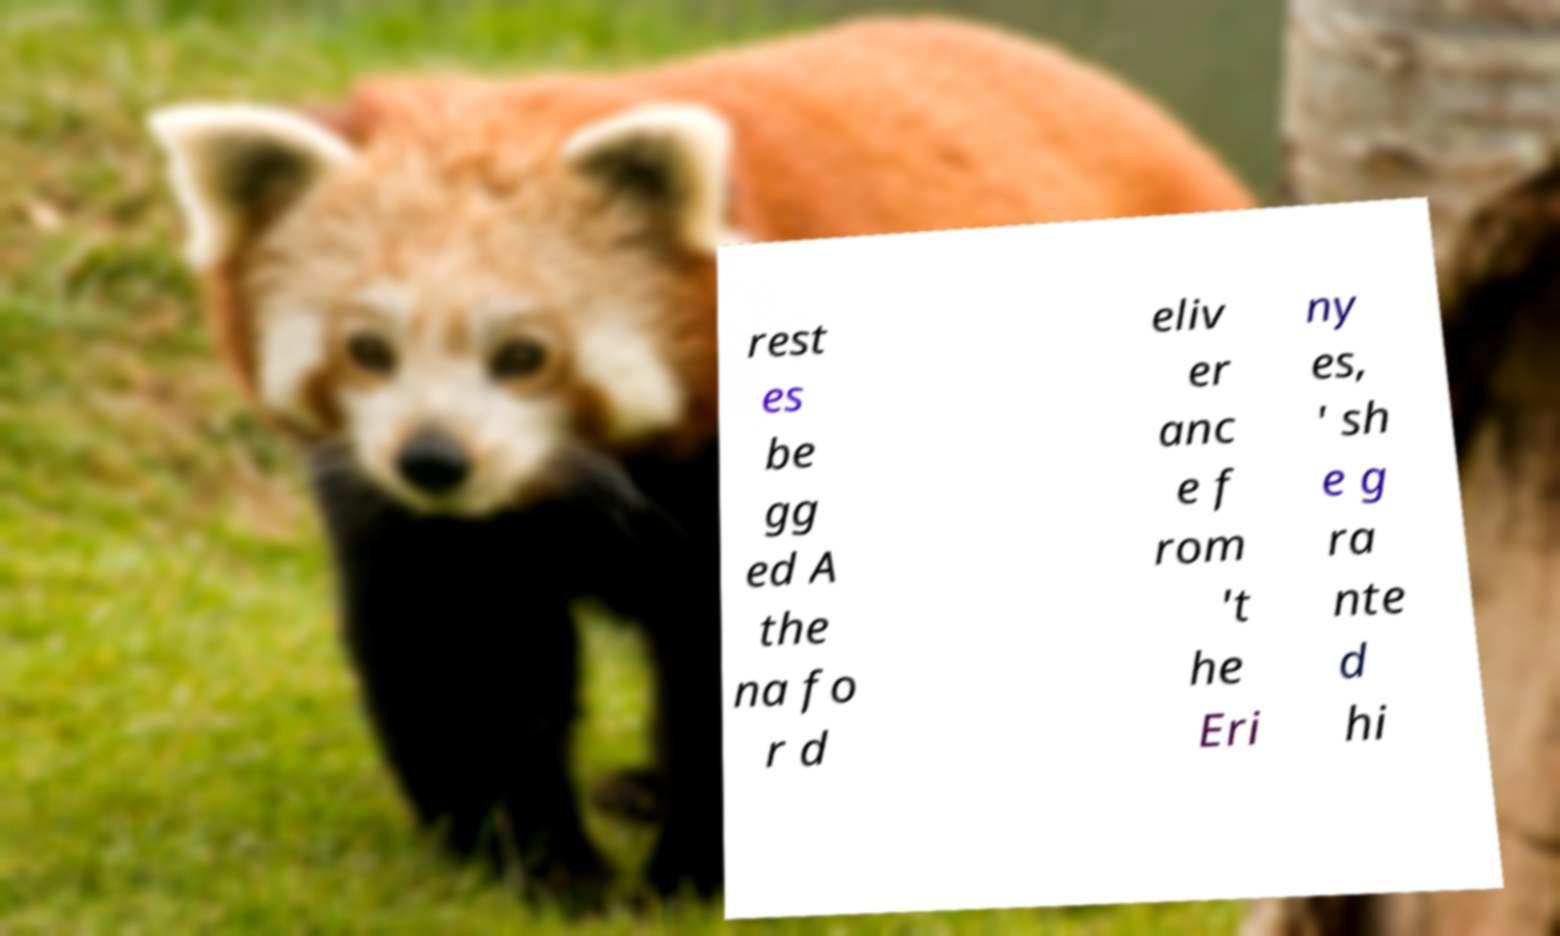Could you assist in decoding the text presented in this image and type it out clearly? rest es be gg ed A the na fo r d eliv er anc e f rom 't he Eri ny es, ' sh e g ra nte d hi 